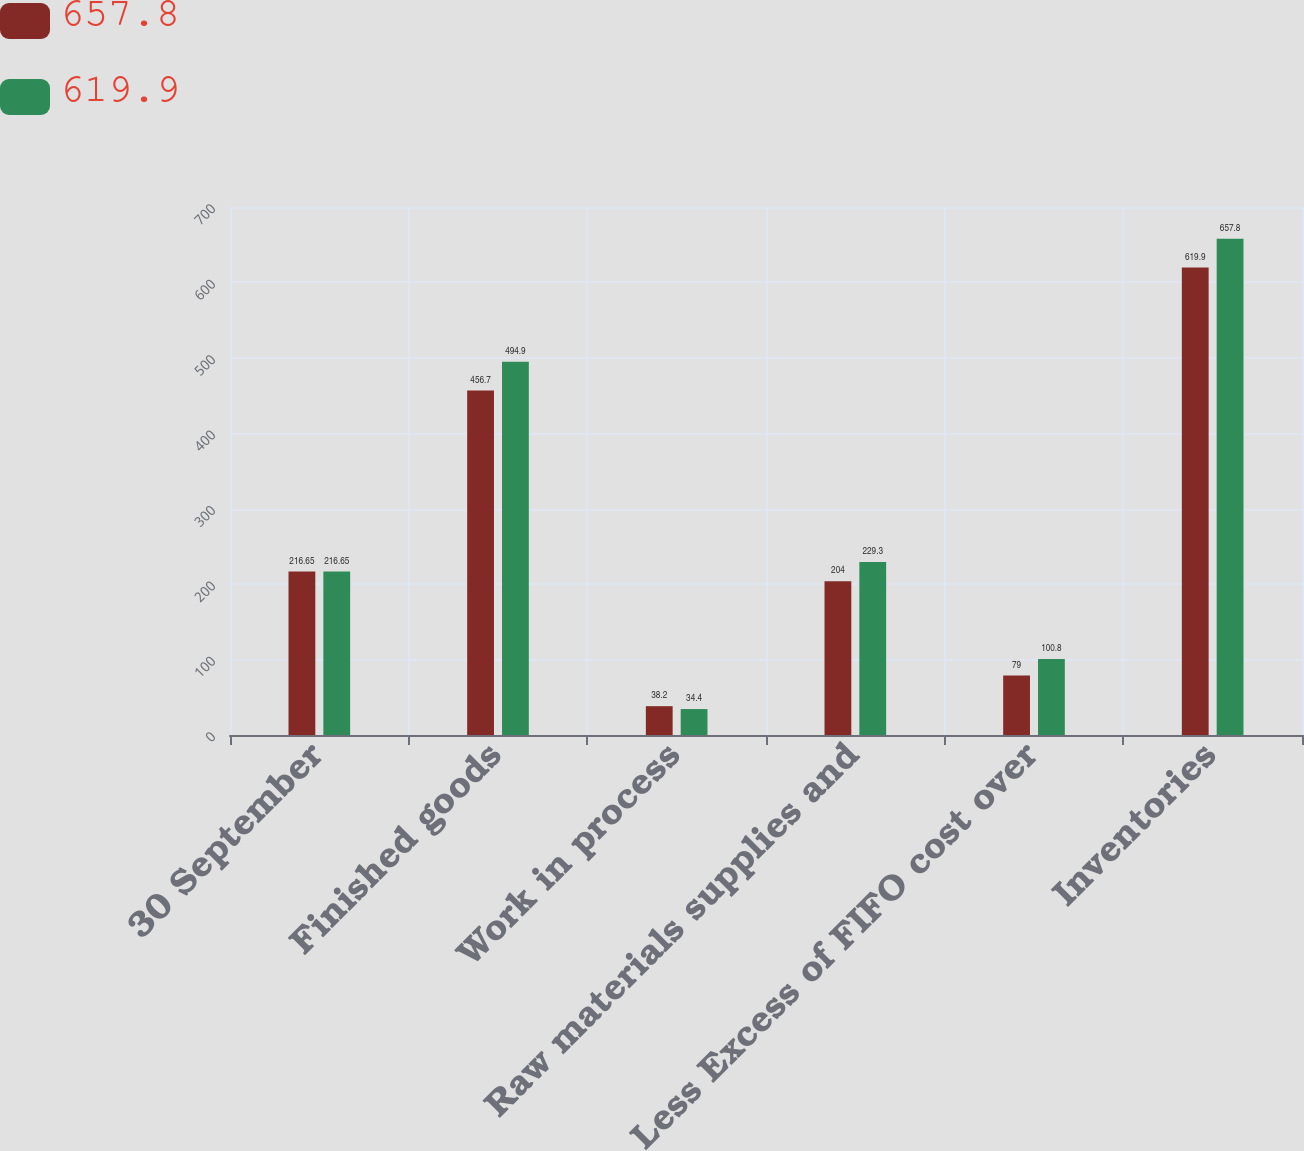<chart> <loc_0><loc_0><loc_500><loc_500><stacked_bar_chart><ecel><fcel>30 September<fcel>Finished goods<fcel>Work in process<fcel>Raw materials supplies and<fcel>Less Excess of FIFO cost over<fcel>Inventories<nl><fcel>657.8<fcel>216.65<fcel>456.7<fcel>38.2<fcel>204<fcel>79<fcel>619.9<nl><fcel>619.9<fcel>216.65<fcel>494.9<fcel>34.4<fcel>229.3<fcel>100.8<fcel>657.8<nl></chart> 